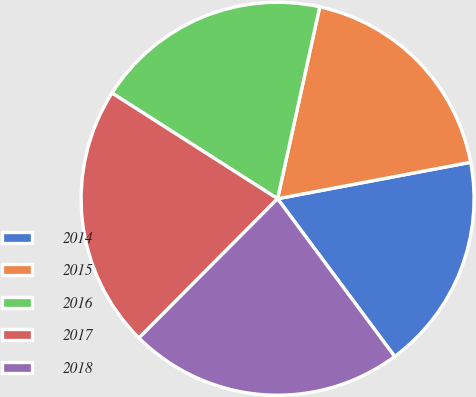Convert chart to OTSL. <chart><loc_0><loc_0><loc_500><loc_500><pie_chart><fcel>2014<fcel>2015<fcel>2016<fcel>2017<fcel>2018<nl><fcel>17.81%<fcel>18.59%<fcel>19.4%<fcel>21.58%<fcel>22.63%<nl></chart> 